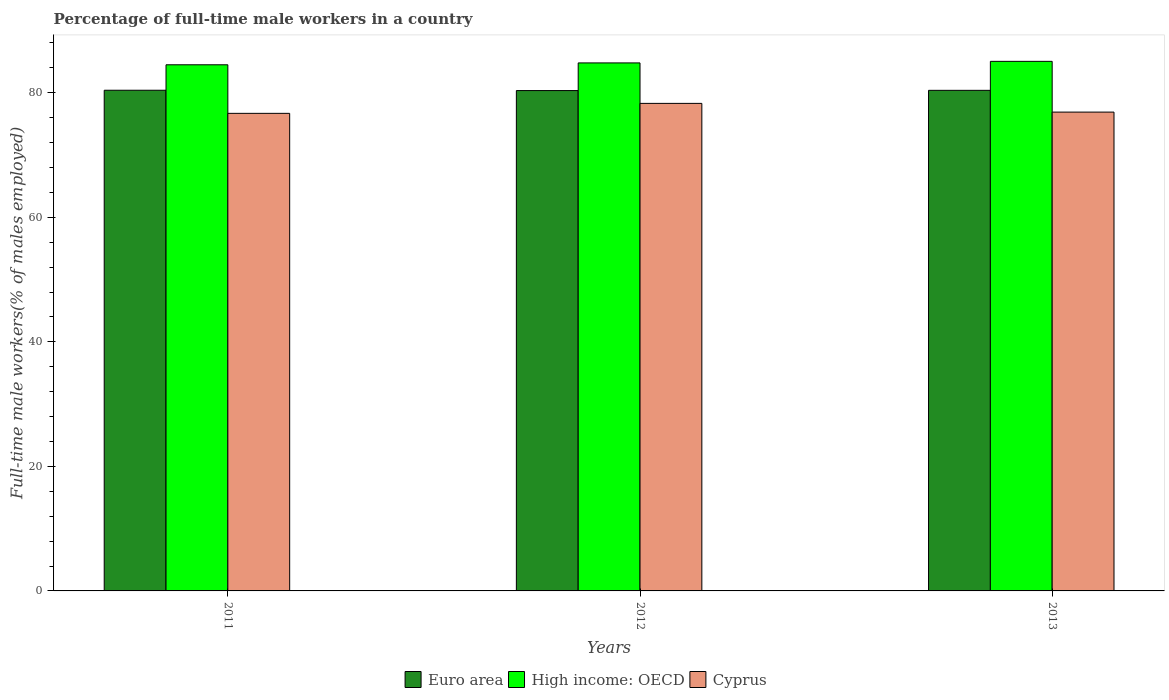How many different coloured bars are there?
Ensure brevity in your answer.  3. How many groups of bars are there?
Your response must be concise. 3. Are the number of bars per tick equal to the number of legend labels?
Your response must be concise. Yes. How many bars are there on the 1st tick from the right?
Ensure brevity in your answer.  3. What is the label of the 3rd group of bars from the left?
Provide a succinct answer. 2013. What is the percentage of full-time male workers in High income: OECD in 2012?
Make the answer very short. 84.8. Across all years, what is the maximum percentage of full-time male workers in High income: OECD?
Keep it short and to the point. 85.05. Across all years, what is the minimum percentage of full-time male workers in Cyprus?
Offer a very short reply. 76.7. In which year was the percentage of full-time male workers in Cyprus minimum?
Offer a terse response. 2011. What is the total percentage of full-time male workers in Euro area in the graph?
Provide a succinct answer. 241.16. What is the difference between the percentage of full-time male workers in Cyprus in 2011 and that in 2012?
Your response must be concise. -1.6. What is the difference between the percentage of full-time male workers in High income: OECD in 2011 and the percentage of full-time male workers in Cyprus in 2013?
Offer a very short reply. 7.6. What is the average percentage of full-time male workers in Euro area per year?
Your response must be concise. 80.39. In the year 2011, what is the difference between the percentage of full-time male workers in High income: OECD and percentage of full-time male workers in Cyprus?
Provide a short and direct response. 7.8. In how many years, is the percentage of full-time male workers in Euro area greater than 28 %?
Your answer should be compact. 3. What is the ratio of the percentage of full-time male workers in Cyprus in 2012 to that in 2013?
Offer a terse response. 1.02. Is the difference between the percentage of full-time male workers in High income: OECD in 2011 and 2013 greater than the difference between the percentage of full-time male workers in Cyprus in 2011 and 2013?
Offer a very short reply. No. What is the difference between the highest and the second highest percentage of full-time male workers in High income: OECD?
Keep it short and to the point. 0.25. What is the difference between the highest and the lowest percentage of full-time male workers in High income: OECD?
Ensure brevity in your answer.  0.55. Is the sum of the percentage of full-time male workers in High income: OECD in 2011 and 2013 greater than the maximum percentage of full-time male workers in Cyprus across all years?
Make the answer very short. Yes. What does the 2nd bar from the left in 2011 represents?
Provide a succinct answer. High income: OECD. Is it the case that in every year, the sum of the percentage of full-time male workers in High income: OECD and percentage of full-time male workers in Cyprus is greater than the percentage of full-time male workers in Euro area?
Your answer should be compact. Yes. What is the difference between two consecutive major ticks on the Y-axis?
Your answer should be compact. 20. Does the graph contain any zero values?
Provide a short and direct response. No. Does the graph contain grids?
Give a very brief answer. No. Where does the legend appear in the graph?
Your answer should be very brief. Bottom center. What is the title of the graph?
Offer a terse response. Percentage of full-time male workers in a country. Does "China" appear as one of the legend labels in the graph?
Your answer should be compact. No. What is the label or title of the X-axis?
Provide a short and direct response. Years. What is the label or title of the Y-axis?
Give a very brief answer. Full-time male workers(% of males employed). What is the Full-time male workers(% of males employed) in Euro area in 2011?
Your answer should be compact. 80.41. What is the Full-time male workers(% of males employed) of High income: OECD in 2011?
Provide a short and direct response. 84.5. What is the Full-time male workers(% of males employed) in Cyprus in 2011?
Keep it short and to the point. 76.7. What is the Full-time male workers(% of males employed) in Euro area in 2012?
Offer a terse response. 80.36. What is the Full-time male workers(% of males employed) of High income: OECD in 2012?
Offer a very short reply. 84.8. What is the Full-time male workers(% of males employed) of Cyprus in 2012?
Provide a succinct answer. 78.3. What is the Full-time male workers(% of males employed) in Euro area in 2013?
Offer a very short reply. 80.4. What is the Full-time male workers(% of males employed) in High income: OECD in 2013?
Offer a very short reply. 85.05. What is the Full-time male workers(% of males employed) in Cyprus in 2013?
Your response must be concise. 76.9. Across all years, what is the maximum Full-time male workers(% of males employed) in Euro area?
Your answer should be very brief. 80.41. Across all years, what is the maximum Full-time male workers(% of males employed) in High income: OECD?
Ensure brevity in your answer.  85.05. Across all years, what is the maximum Full-time male workers(% of males employed) in Cyprus?
Ensure brevity in your answer.  78.3. Across all years, what is the minimum Full-time male workers(% of males employed) of Euro area?
Give a very brief answer. 80.36. Across all years, what is the minimum Full-time male workers(% of males employed) of High income: OECD?
Ensure brevity in your answer.  84.5. Across all years, what is the minimum Full-time male workers(% of males employed) of Cyprus?
Your response must be concise. 76.7. What is the total Full-time male workers(% of males employed) of Euro area in the graph?
Make the answer very short. 241.16. What is the total Full-time male workers(% of males employed) in High income: OECD in the graph?
Make the answer very short. 254.35. What is the total Full-time male workers(% of males employed) in Cyprus in the graph?
Give a very brief answer. 231.9. What is the difference between the Full-time male workers(% of males employed) of Euro area in 2011 and that in 2012?
Ensure brevity in your answer.  0.05. What is the difference between the Full-time male workers(% of males employed) of High income: OECD in 2011 and that in 2012?
Your response must be concise. -0.3. What is the difference between the Full-time male workers(% of males employed) in Euro area in 2011 and that in 2013?
Give a very brief answer. 0.01. What is the difference between the Full-time male workers(% of males employed) of High income: OECD in 2011 and that in 2013?
Make the answer very short. -0.55. What is the difference between the Full-time male workers(% of males employed) in Cyprus in 2011 and that in 2013?
Give a very brief answer. -0.2. What is the difference between the Full-time male workers(% of males employed) in Euro area in 2012 and that in 2013?
Your answer should be compact. -0.04. What is the difference between the Full-time male workers(% of males employed) in High income: OECD in 2012 and that in 2013?
Give a very brief answer. -0.25. What is the difference between the Full-time male workers(% of males employed) in Cyprus in 2012 and that in 2013?
Ensure brevity in your answer.  1.4. What is the difference between the Full-time male workers(% of males employed) of Euro area in 2011 and the Full-time male workers(% of males employed) of High income: OECD in 2012?
Offer a terse response. -4.39. What is the difference between the Full-time male workers(% of males employed) of Euro area in 2011 and the Full-time male workers(% of males employed) of Cyprus in 2012?
Provide a succinct answer. 2.11. What is the difference between the Full-time male workers(% of males employed) in High income: OECD in 2011 and the Full-time male workers(% of males employed) in Cyprus in 2012?
Your response must be concise. 6.2. What is the difference between the Full-time male workers(% of males employed) in Euro area in 2011 and the Full-time male workers(% of males employed) in High income: OECD in 2013?
Your answer should be compact. -4.64. What is the difference between the Full-time male workers(% of males employed) in Euro area in 2011 and the Full-time male workers(% of males employed) in Cyprus in 2013?
Make the answer very short. 3.51. What is the difference between the Full-time male workers(% of males employed) in High income: OECD in 2011 and the Full-time male workers(% of males employed) in Cyprus in 2013?
Your answer should be very brief. 7.6. What is the difference between the Full-time male workers(% of males employed) of Euro area in 2012 and the Full-time male workers(% of males employed) of High income: OECD in 2013?
Make the answer very short. -4.69. What is the difference between the Full-time male workers(% of males employed) of Euro area in 2012 and the Full-time male workers(% of males employed) of Cyprus in 2013?
Provide a succinct answer. 3.46. What is the difference between the Full-time male workers(% of males employed) in High income: OECD in 2012 and the Full-time male workers(% of males employed) in Cyprus in 2013?
Your response must be concise. 7.9. What is the average Full-time male workers(% of males employed) in Euro area per year?
Give a very brief answer. 80.39. What is the average Full-time male workers(% of males employed) of High income: OECD per year?
Ensure brevity in your answer.  84.78. What is the average Full-time male workers(% of males employed) in Cyprus per year?
Offer a terse response. 77.3. In the year 2011, what is the difference between the Full-time male workers(% of males employed) of Euro area and Full-time male workers(% of males employed) of High income: OECD?
Offer a terse response. -4.09. In the year 2011, what is the difference between the Full-time male workers(% of males employed) of Euro area and Full-time male workers(% of males employed) of Cyprus?
Make the answer very short. 3.71. In the year 2011, what is the difference between the Full-time male workers(% of males employed) of High income: OECD and Full-time male workers(% of males employed) of Cyprus?
Give a very brief answer. 7.8. In the year 2012, what is the difference between the Full-time male workers(% of males employed) in Euro area and Full-time male workers(% of males employed) in High income: OECD?
Your response must be concise. -4.44. In the year 2012, what is the difference between the Full-time male workers(% of males employed) in Euro area and Full-time male workers(% of males employed) in Cyprus?
Ensure brevity in your answer.  2.06. In the year 2012, what is the difference between the Full-time male workers(% of males employed) of High income: OECD and Full-time male workers(% of males employed) of Cyprus?
Give a very brief answer. 6.5. In the year 2013, what is the difference between the Full-time male workers(% of males employed) of Euro area and Full-time male workers(% of males employed) of High income: OECD?
Provide a short and direct response. -4.65. In the year 2013, what is the difference between the Full-time male workers(% of males employed) in Euro area and Full-time male workers(% of males employed) in Cyprus?
Provide a succinct answer. 3.5. In the year 2013, what is the difference between the Full-time male workers(% of males employed) of High income: OECD and Full-time male workers(% of males employed) of Cyprus?
Give a very brief answer. 8.15. What is the ratio of the Full-time male workers(% of males employed) in High income: OECD in 2011 to that in 2012?
Offer a terse response. 1. What is the ratio of the Full-time male workers(% of males employed) in Cyprus in 2011 to that in 2012?
Your answer should be very brief. 0.98. What is the ratio of the Full-time male workers(% of males employed) of Euro area in 2011 to that in 2013?
Provide a short and direct response. 1. What is the ratio of the Full-time male workers(% of males employed) of High income: OECD in 2011 to that in 2013?
Provide a short and direct response. 0.99. What is the ratio of the Full-time male workers(% of males employed) in Cyprus in 2011 to that in 2013?
Offer a terse response. 1. What is the ratio of the Full-time male workers(% of males employed) in Cyprus in 2012 to that in 2013?
Your response must be concise. 1.02. What is the difference between the highest and the second highest Full-time male workers(% of males employed) in Euro area?
Provide a short and direct response. 0.01. What is the difference between the highest and the second highest Full-time male workers(% of males employed) of High income: OECD?
Provide a succinct answer. 0.25. What is the difference between the highest and the lowest Full-time male workers(% of males employed) in Euro area?
Keep it short and to the point. 0.05. What is the difference between the highest and the lowest Full-time male workers(% of males employed) of High income: OECD?
Your answer should be compact. 0.55. What is the difference between the highest and the lowest Full-time male workers(% of males employed) of Cyprus?
Offer a very short reply. 1.6. 